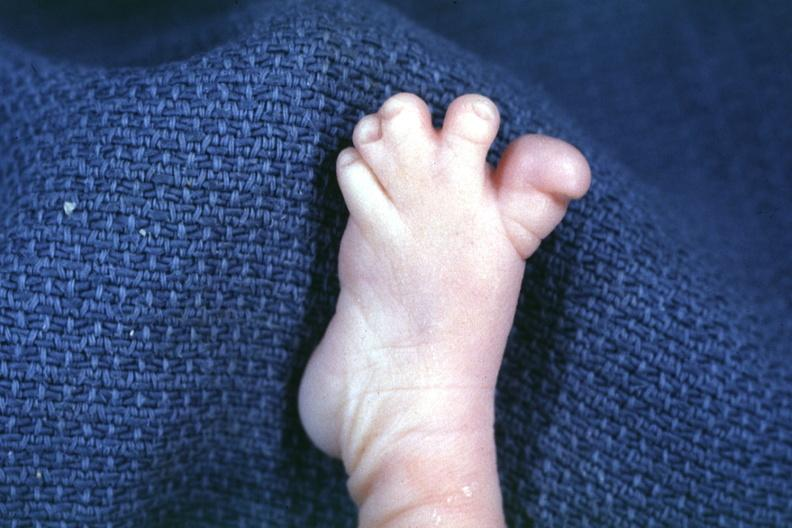s anomalous origin present?
Answer the question using a single word or phrase. No 